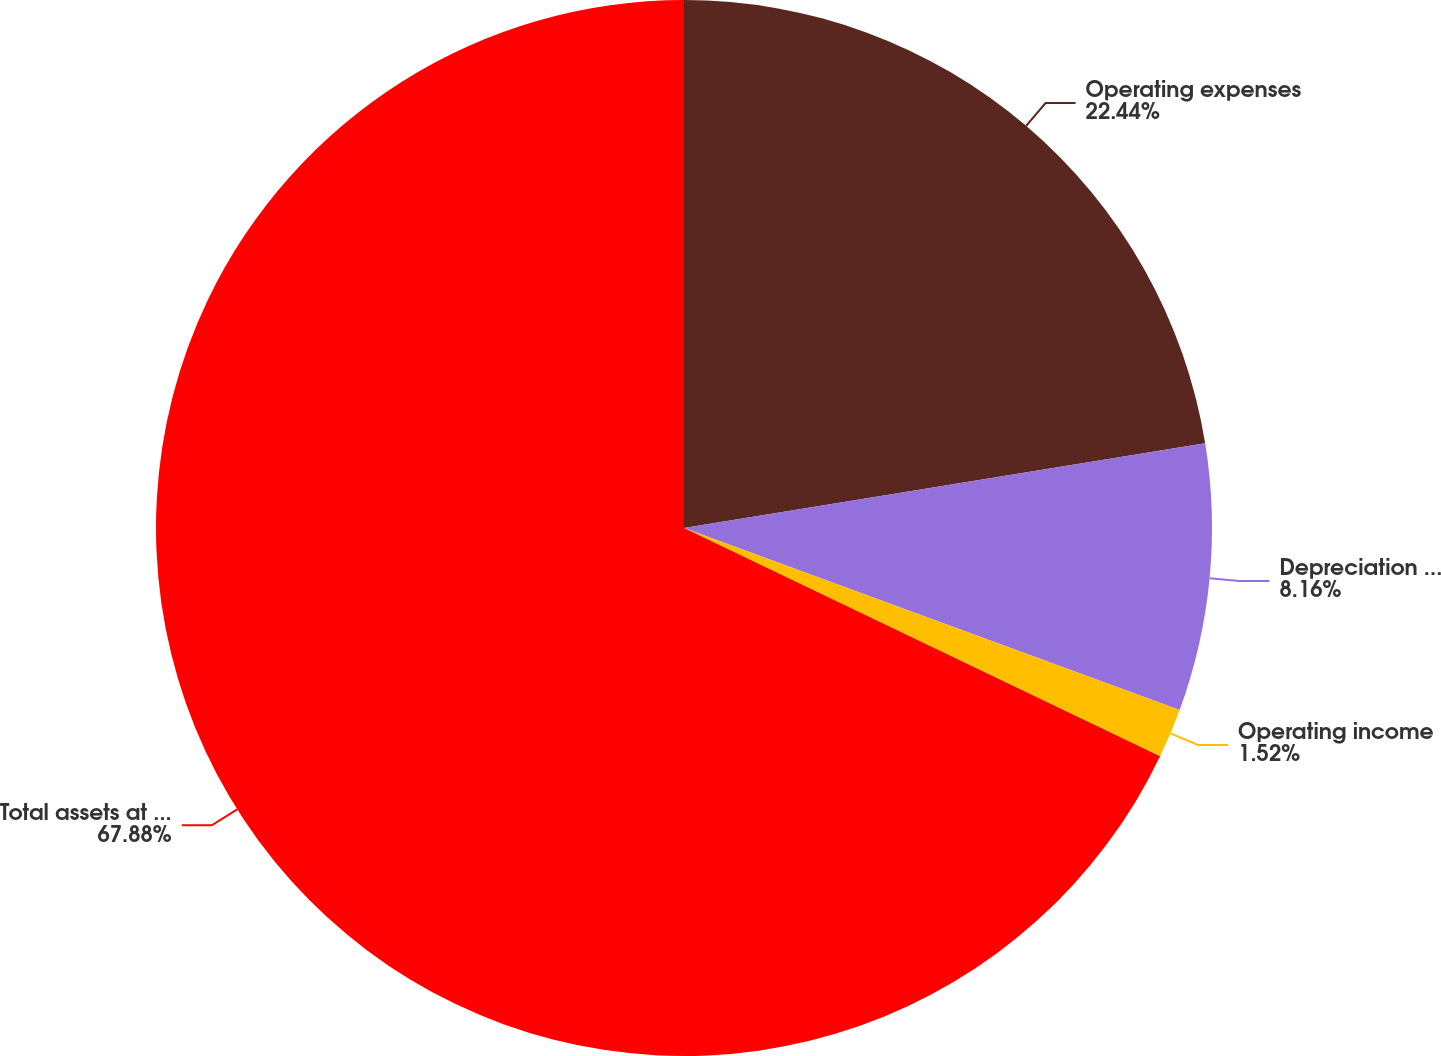Convert chart. <chart><loc_0><loc_0><loc_500><loc_500><pie_chart><fcel>Operating expenses<fcel>Depreciation and amortization<fcel>Operating income<fcel>Total assets at December 31<nl><fcel>22.44%<fcel>8.16%<fcel>1.52%<fcel>67.89%<nl></chart> 